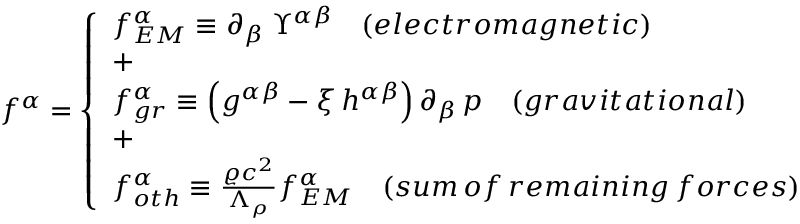Convert formula to latex. <formula><loc_0><loc_0><loc_500><loc_500>f ^ { \alpha } = \left \{ \begin{array} { l l } { f _ { E M } ^ { \alpha } \equiv \partial _ { \beta } \, \Upsilon ^ { \alpha \beta } \quad ( e l e c t r o m a g n e t i c ) } \\ { + } \\ { f _ { g r } ^ { \alpha } \equiv \left ( g ^ { \alpha \beta } - \xi \, h ^ { \alpha \beta } \right ) \partial _ { \beta } \, p \quad ( g r a v i t a t i o n a l ) } \\ { + } \\ { f _ { o t h } ^ { \alpha } \equiv \frac { \varrho c ^ { 2 } } { \Lambda _ { \rho } } f _ { E M } ^ { \alpha } \quad ( s u m \, o f \, r e m a i n i n g \, f o r c e s ) } \end{array}</formula> 